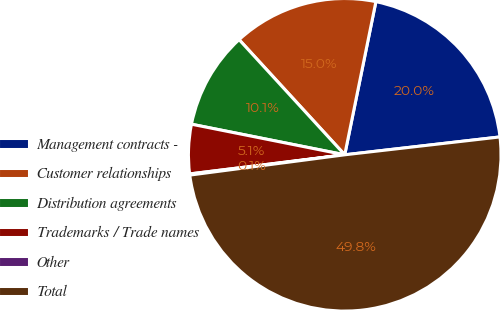Convert chart to OTSL. <chart><loc_0><loc_0><loc_500><loc_500><pie_chart><fcel>Management contracts -<fcel>Customer relationships<fcel>Distribution agreements<fcel>Trademarks / Trade names<fcel>Other<fcel>Total<nl><fcel>19.98%<fcel>15.01%<fcel>10.05%<fcel>5.09%<fcel>0.12%<fcel>49.75%<nl></chart> 